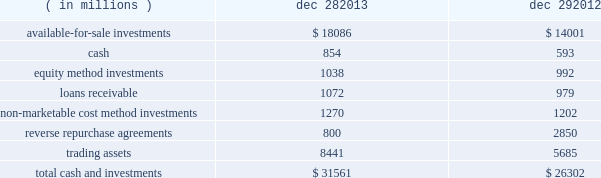The fair value of our grants receivable is determined using a discounted cash flow model , which discounts future cash flows using an appropriate yield curve .
As of december 28 , 2013 , and december 29 , 2012 , the carrying amount of our grants receivable was classified within other current assets and other long-term assets , as applicable .
Our long-term debt recognized at amortized cost is comprised of our senior notes and our convertible debentures .
The fair value of our senior notes is determined using active market prices , and it is therefore classified as level 1 .
The fair value of our convertible long-term debt is determined using discounted cash flow models with observable market inputs , and it takes into consideration variables such as interest rate changes , comparable securities , subordination discount , and credit-rating changes , and it is therefore classified as level 2 .
The nvidia corporation ( nvidia ) cross-license agreement liability in the preceding table was incurred as a result of entering into a long-term patent cross-license agreement with nvidia in january 2011 .
We agreed to make payments to nvidia over six years .
As of december 28 , 2013 , and december 29 , 2012 , the carrying amount of the liability arising from the agreement was classified within other accrued liabilities and other long-term liabilities , as applicable .
The fair value is determined using a discounted cash flow model , which discounts future cash flows using our incremental borrowing rates .
Note 5 : cash and investments cash and investments at the end of each period were as follows : ( in millions ) dec 28 , dec 29 .
In the third quarter of 2013 , we sold our shares in clearwire corporation , which had been accounted for as available-for-sale marketable equity securities , and our interest in clearwire communications , llc ( clearwire llc ) , which had been accounted for as an equity method investment .
In total , we received proceeds of $ 470 million on these transactions and recognized a gain of $ 439 million , which is included in gains ( losses ) on equity investments , net on the consolidated statements of income .
Proceeds received and gains recognized for each investment are included in the "available-for-sale investments" and "equity method investments" sections that follow .
Table of contents intel corporation notes to consolidated financial statements ( continued ) .
What percentage of total cash and investments as of dec . 28 2013 was comprised of available-for-sale investments? 
Computations: (18086 / 31561)
Answer: 0.57305. 